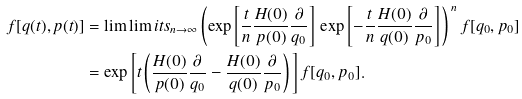<formula> <loc_0><loc_0><loc_500><loc_500>f [ q ( t ) , p ( t ) ] & = \lim \lim i t s _ { n \to \infty } \left ( \exp \left [ \frac { t } { n } \frac { H ( 0 ) } { p ( 0 ) } \frac { \partial } { q _ { 0 } } \right ] \, \exp \left [ - \frac { t } { n } \frac { H ( 0 ) } { q ( 0 ) } \frac { \partial } { p _ { 0 } } \right ] \Big . \right ) ^ { \, n } f [ q _ { 0 } , p _ { 0 } ] \\ & = \exp \left [ t \left ( \frac { H ( 0 ) } { p ( 0 ) } \frac { \partial } { q _ { 0 } } - \frac { H ( 0 ) } { q ( 0 ) } \frac { \partial } { p _ { 0 } } \right ) \Big . \right ] f [ q _ { 0 } , p _ { 0 } ] .</formula> 